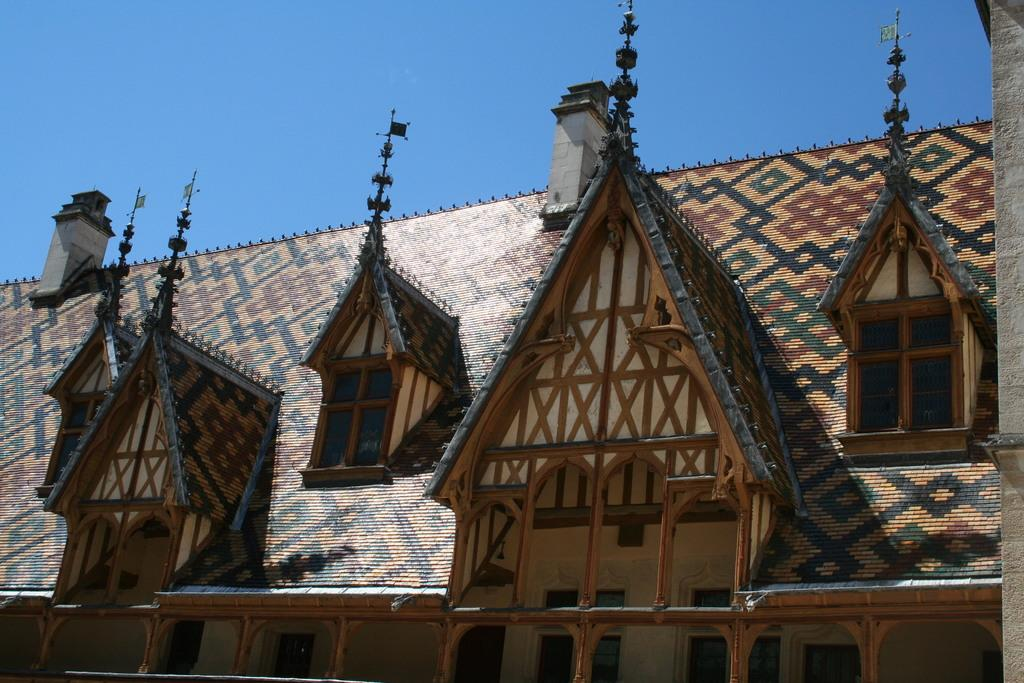What type of structure is visible in the image? There is a house in the image. What are some features of the house? The house has a roof, pillars, and windows. What else can be seen on the right side of the image? There is a pole on the right side of the image. What is visible in the background of the image? The sky is visible in the image, and it appears to be cloudy. Can you tell me how many tigers are in the room inside the house? There is no room or tiger mentioned in the image; it only shows the exterior of the house with a cloudy sky in the background. 